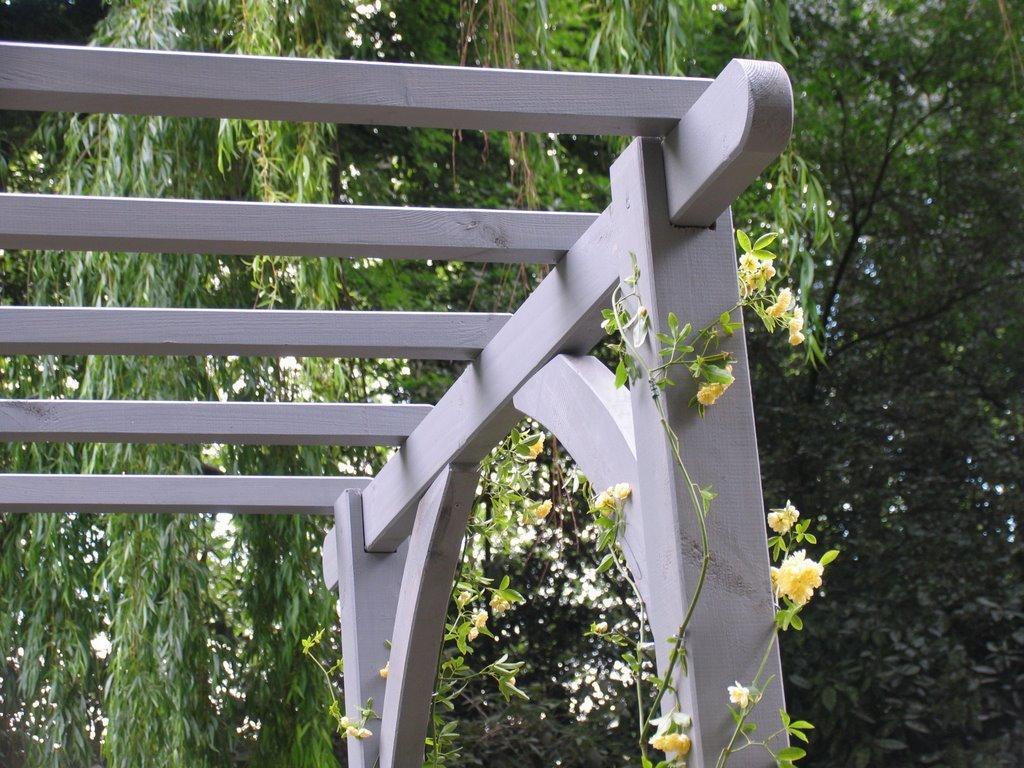Could you give a brief overview of what you see in this image? In this image I can see the ash color wooden object. In the background I ca see many trees and I can see some yellow color flowers to the plant. 